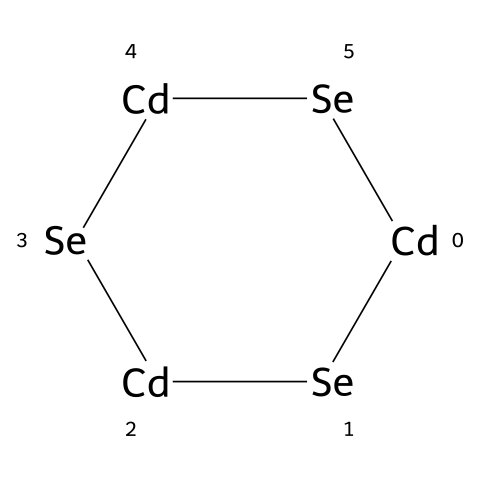What is the main metal in this quantum dot structure? The SMILES representation indicates the presence of cadmium atoms, denoted by [Cd]. Cadmium is the primary metal in this quantum dot structure.
Answer: cadmium How many selenium atoms are present in this structure? In the SMILES notation, each [Se] represents a selenium atom. There are three [Se] in the representation, indicating there are three selenium atoms.
Answer: three What type of chemical bonding is predominantly present in this chemical? The quantum dot structure features metal-ligand bonds between cadmium and selenium atoms. Additionally, the arrangement suggests covalent bonds as the main type of bonding within the structure.
Answer: covalent What is the total number of atoms in this quantum dot? Counting the atoms shown in the SMILES notation, we find three cadmium atoms and three selenium atoms, totaling six atoms in this quantum dot.
Answer: six Is this quantum dot likely to be a semiconductor material? Given that cadmium selenide (the material implied by cadmium and selenium in the structure) is well-known for its semiconductor properties, this quantum dot is likely classified as a semiconductor.
Answer: yes What role do quantum dots play in anti-doping detection technologies? Quantum dots are commonly used as fluorescent markers in detection technologies due to their size-dependent optical properties, which enhance the sensitivity and specificity of tests, particularly in identifying prohibited substances.
Answer: fluorescent markers 